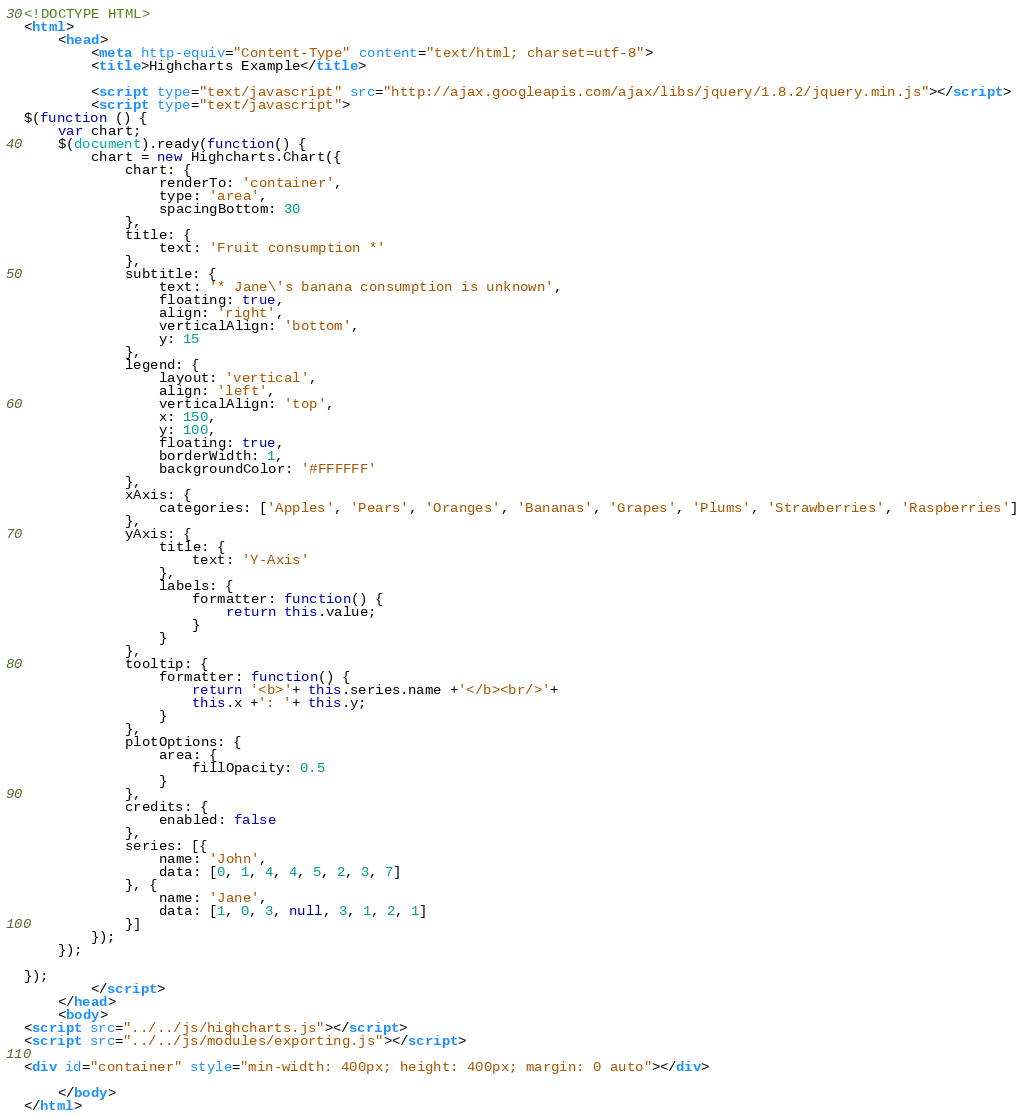<code> <loc_0><loc_0><loc_500><loc_500><_HTML_><!DOCTYPE HTML>
<html>
	<head>
		<meta http-equiv="Content-Type" content="text/html; charset=utf-8">
		<title>Highcharts Example</title>

		<script type="text/javascript" src="http://ajax.googleapis.com/ajax/libs/jquery/1.8.2/jquery.min.js"></script>
		<script type="text/javascript">
$(function () {
    var chart;
    $(document).ready(function() {
        chart = new Highcharts.Chart({
            chart: {
                renderTo: 'container',
                type: 'area',
                spacingBottom: 30
            },
            title: {
                text: 'Fruit consumption *'
            },
            subtitle: {
                text: '* Jane\'s banana consumption is unknown',
                floating: true,
                align: 'right',
                verticalAlign: 'bottom',
                y: 15
            },
            legend: {
                layout: 'vertical',
                align: 'left',
                verticalAlign: 'top',
                x: 150,
                y: 100,
                floating: true,
                borderWidth: 1,
                backgroundColor: '#FFFFFF'
            },
            xAxis: {
                categories: ['Apples', 'Pears', 'Oranges', 'Bananas', 'Grapes', 'Plums', 'Strawberries', 'Raspberries']
            },
            yAxis: {
                title: {
                    text: 'Y-Axis'
                },
                labels: {
                    formatter: function() {
                        return this.value;
                    }
                }
            },
            tooltip: {
                formatter: function() {
                    return '<b>'+ this.series.name +'</b><br/>'+
                    this.x +': '+ this.y;
                }
            },
            plotOptions: {
                area: {
                    fillOpacity: 0.5
                }
            },
            credits: {
                enabled: false
            },
            series: [{
                name: 'John',
                data: [0, 1, 4, 4, 5, 2, 3, 7]
            }, {
                name: 'Jane',
                data: [1, 0, 3, null, 3, 1, 2, 1]
            }]
        });
    });
    
});
		</script>
	</head>
	<body>
<script src="../../js/highcharts.js"></script>
<script src="../../js/modules/exporting.js"></script>

<div id="container" style="min-width: 400px; height: 400px; margin: 0 auto"></div>

	</body>
</html>
</code> 